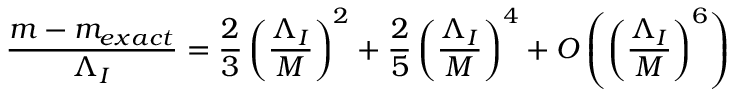Convert formula to latex. <formula><loc_0><loc_0><loc_500><loc_500>\frac { m - m _ { e x a c t } } { \Lambda _ { I } } = \frac { 2 } { 3 } \left ( \frac { \Lambda _ { I } } { M } \right ) ^ { 2 } + \frac { 2 } { 5 } \left ( \frac { \Lambda _ { I } } { M } \right ) ^ { 4 } + O \left ( \left ( \frac { \Lambda _ { I } } { M } \right ) ^ { 6 } \right )</formula> 